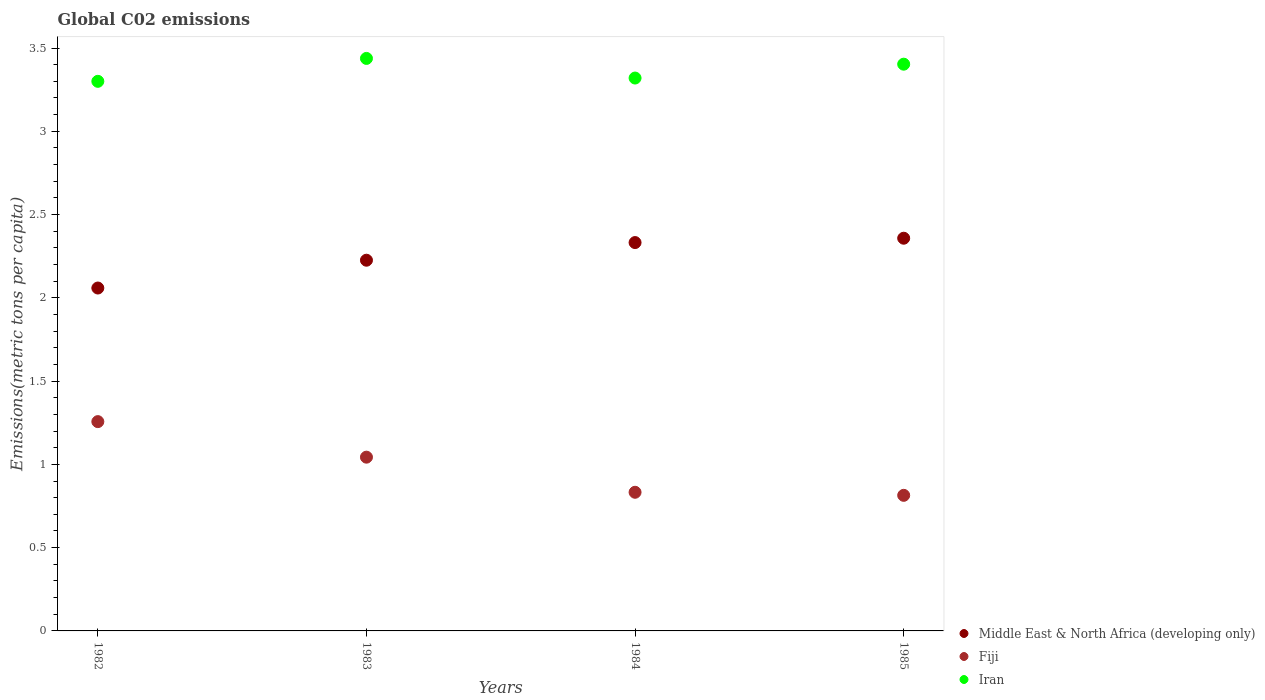Is the number of dotlines equal to the number of legend labels?
Ensure brevity in your answer.  Yes. What is the amount of CO2 emitted in in Middle East & North Africa (developing only) in 1983?
Your answer should be compact. 2.23. Across all years, what is the maximum amount of CO2 emitted in in Fiji?
Offer a very short reply. 1.26. Across all years, what is the minimum amount of CO2 emitted in in Fiji?
Provide a short and direct response. 0.81. What is the total amount of CO2 emitted in in Middle East & North Africa (developing only) in the graph?
Keep it short and to the point. 8.97. What is the difference between the amount of CO2 emitted in in Middle East & North Africa (developing only) in 1983 and that in 1985?
Provide a succinct answer. -0.13. What is the difference between the amount of CO2 emitted in in Fiji in 1984 and the amount of CO2 emitted in in Iran in 1983?
Give a very brief answer. -2.61. What is the average amount of CO2 emitted in in Iran per year?
Give a very brief answer. 3.37. In the year 1982, what is the difference between the amount of CO2 emitted in in Iran and amount of CO2 emitted in in Fiji?
Ensure brevity in your answer.  2.04. In how many years, is the amount of CO2 emitted in in Fiji greater than 3 metric tons per capita?
Offer a terse response. 0. What is the ratio of the amount of CO2 emitted in in Middle East & North Africa (developing only) in 1983 to that in 1985?
Make the answer very short. 0.94. Is the amount of CO2 emitted in in Iran in 1984 less than that in 1985?
Offer a terse response. Yes. Is the difference between the amount of CO2 emitted in in Iran in 1982 and 1984 greater than the difference between the amount of CO2 emitted in in Fiji in 1982 and 1984?
Make the answer very short. No. What is the difference between the highest and the second highest amount of CO2 emitted in in Iran?
Ensure brevity in your answer.  0.03. What is the difference between the highest and the lowest amount of CO2 emitted in in Fiji?
Give a very brief answer. 0.44. Is it the case that in every year, the sum of the amount of CO2 emitted in in Middle East & North Africa (developing only) and amount of CO2 emitted in in Iran  is greater than the amount of CO2 emitted in in Fiji?
Your answer should be compact. Yes. Does the amount of CO2 emitted in in Iran monotonically increase over the years?
Offer a very short reply. No. Is the amount of CO2 emitted in in Iran strictly greater than the amount of CO2 emitted in in Middle East & North Africa (developing only) over the years?
Provide a short and direct response. Yes. Is the amount of CO2 emitted in in Middle East & North Africa (developing only) strictly less than the amount of CO2 emitted in in Iran over the years?
Provide a short and direct response. Yes. Are the values on the major ticks of Y-axis written in scientific E-notation?
Give a very brief answer. No. Does the graph contain grids?
Provide a short and direct response. No. How many legend labels are there?
Provide a short and direct response. 3. What is the title of the graph?
Keep it short and to the point. Global C02 emissions. Does "Antigua and Barbuda" appear as one of the legend labels in the graph?
Your response must be concise. No. What is the label or title of the Y-axis?
Make the answer very short. Emissions(metric tons per capita). What is the Emissions(metric tons per capita) in Middle East & North Africa (developing only) in 1982?
Your response must be concise. 2.06. What is the Emissions(metric tons per capita) of Fiji in 1982?
Your response must be concise. 1.26. What is the Emissions(metric tons per capita) of Iran in 1982?
Keep it short and to the point. 3.3. What is the Emissions(metric tons per capita) of Middle East & North Africa (developing only) in 1983?
Your answer should be very brief. 2.23. What is the Emissions(metric tons per capita) in Fiji in 1983?
Keep it short and to the point. 1.04. What is the Emissions(metric tons per capita) in Iran in 1983?
Provide a succinct answer. 3.44. What is the Emissions(metric tons per capita) of Middle East & North Africa (developing only) in 1984?
Your answer should be very brief. 2.33. What is the Emissions(metric tons per capita) in Fiji in 1984?
Make the answer very short. 0.83. What is the Emissions(metric tons per capita) of Iran in 1984?
Make the answer very short. 3.32. What is the Emissions(metric tons per capita) of Middle East & North Africa (developing only) in 1985?
Keep it short and to the point. 2.36. What is the Emissions(metric tons per capita) in Fiji in 1985?
Offer a terse response. 0.81. What is the Emissions(metric tons per capita) of Iran in 1985?
Provide a short and direct response. 3.4. Across all years, what is the maximum Emissions(metric tons per capita) in Middle East & North Africa (developing only)?
Offer a terse response. 2.36. Across all years, what is the maximum Emissions(metric tons per capita) of Fiji?
Your answer should be compact. 1.26. Across all years, what is the maximum Emissions(metric tons per capita) of Iran?
Ensure brevity in your answer.  3.44. Across all years, what is the minimum Emissions(metric tons per capita) in Middle East & North Africa (developing only)?
Ensure brevity in your answer.  2.06. Across all years, what is the minimum Emissions(metric tons per capita) in Fiji?
Your answer should be very brief. 0.81. Across all years, what is the minimum Emissions(metric tons per capita) in Iran?
Ensure brevity in your answer.  3.3. What is the total Emissions(metric tons per capita) in Middle East & North Africa (developing only) in the graph?
Make the answer very short. 8.97. What is the total Emissions(metric tons per capita) of Fiji in the graph?
Provide a succinct answer. 3.95. What is the total Emissions(metric tons per capita) of Iran in the graph?
Ensure brevity in your answer.  13.46. What is the difference between the Emissions(metric tons per capita) of Middle East & North Africa (developing only) in 1982 and that in 1983?
Make the answer very short. -0.17. What is the difference between the Emissions(metric tons per capita) of Fiji in 1982 and that in 1983?
Provide a succinct answer. 0.21. What is the difference between the Emissions(metric tons per capita) in Iran in 1982 and that in 1983?
Offer a terse response. -0.14. What is the difference between the Emissions(metric tons per capita) in Middle East & North Africa (developing only) in 1982 and that in 1984?
Make the answer very short. -0.27. What is the difference between the Emissions(metric tons per capita) of Fiji in 1982 and that in 1984?
Your answer should be very brief. 0.42. What is the difference between the Emissions(metric tons per capita) of Iran in 1982 and that in 1984?
Offer a very short reply. -0.02. What is the difference between the Emissions(metric tons per capita) in Middle East & North Africa (developing only) in 1982 and that in 1985?
Offer a very short reply. -0.3. What is the difference between the Emissions(metric tons per capita) of Fiji in 1982 and that in 1985?
Offer a very short reply. 0.44. What is the difference between the Emissions(metric tons per capita) of Iran in 1982 and that in 1985?
Give a very brief answer. -0.1. What is the difference between the Emissions(metric tons per capita) in Middle East & North Africa (developing only) in 1983 and that in 1984?
Offer a terse response. -0.11. What is the difference between the Emissions(metric tons per capita) in Fiji in 1983 and that in 1984?
Keep it short and to the point. 0.21. What is the difference between the Emissions(metric tons per capita) of Iran in 1983 and that in 1984?
Provide a succinct answer. 0.12. What is the difference between the Emissions(metric tons per capita) in Middle East & North Africa (developing only) in 1983 and that in 1985?
Ensure brevity in your answer.  -0.13. What is the difference between the Emissions(metric tons per capita) of Fiji in 1983 and that in 1985?
Provide a succinct answer. 0.23. What is the difference between the Emissions(metric tons per capita) in Iran in 1983 and that in 1985?
Provide a short and direct response. 0.03. What is the difference between the Emissions(metric tons per capita) of Middle East & North Africa (developing only) in 1984 and that in 1985?
Provide a succinct answer. -0.03. What is the difference between the Emissions(metric tons per capita) of Fiji in 1984 and that in 1985?
Provide a succinct answer. 0.02. What is the difference between the Emissions(metric tons per capita) in Iran in 1984 and that in 1985?
Your answer should be very brief. -0.08. What is the difference between the Emissions(metric tons per capita) in Middle East & North Africa (developing only) in 1982 and the Emissions(metric tons per capita) in Fiji in 1983?
Ensure brevity in your answer.  1.02. What is the difference between the Emissions(metric tons per capita) in Middle East & North Africa (developing only) in 1982 and the Emissions(metric tons per capita) in Iran in 1983?
Keep it short and to the point. -1.38. What is the difference between the Emissions(metric tons per capita) in Fiji in 1982 and the Emissions(metric tons per capita) in Iran in 1983?
Provide a succinct answer. -2.18. What is the difference between the Emissions(metric tons per capita) in Middle East & North Africa (developing only) in 1982 and the Emissions(metric tons per capita) in Fiji in 1984?
Your answer should be very brief. 1.23. What is the difference between the Emissions(metric tons per capita) in Middle East & North Africa (developing only) in 1982 and the Emissions(metric tons per capita) in Iran in 1984?
Provide a short and direct response. -1.26. What is the difference between the Emissions(metric tons per capita) of Fiji in 1982 and the Emissions(metric tons per capita) of Iran in 1984?
Your answer should be very brief. -2.06. What is the difference between the Emissions(metric tons per capita) of Middle East & North Africa (developing only) in 1982 and the Emissions(metric tons per capita) of Fiji in 1985?
Give a very brief answer. 1.24. What is the difference between the Emissions(metric tons per capita) in Middle East & North Africa (developing only) in 1982 and the Emissions(metric tons per capita) in Iran in 1985?
Your response must be concise. -1.34. What is the difference between the Emissions(metric tons per capita) in Fiji in 1982 and the Emissions(metric tons per capita) in Iran in 1985?
Provide a succinct answer. -2.15. What is the difference between the Emissions(metric tons per capita) in Middle East & North Africa (developing only) in 1983 and the Emissions(metric tons per capita) in Fiji in 1984?
Offer a very short reply. 1.39. What is the difference between the Emissions(metric tons per capita) of Middle East & North Africa (developing only) in 1983 and the Emissions(metric tons per capita) of Iran in 1984?
Your answer should be compact. -1.09. What is the difference between the Emissions(metric tons per capita) in Fiji in 1983 and the Emissions(metric tons per capita) in Iran in 1984?
Your answer should be very brief. -2.28. What is the difference between the Emissions(metric tons per capita) of Middle East & North Africa (developing only) in 1983 and the Emissions(metric tons per capita) of Fiji in 1985?
Your response must be concise. 1.41. What is the difference between the Emissions(metric tons per capita) of Middle East & North Africa (developing only) in 1983 and the Emissions(metric tons per capita) of Iran in 1985?
Your answer should be very brief. -1.18. What is the difference between the Emissions(metric tons per capita) in Fiji in 1983 and the Emissions(metric tons per capita) in Iran in 1985?
Provide a succinct answer. -2.36. What is the difference between the Emissions(metric tons per capita) in Middle East & North Africa (developing only) in 1984 and the Emissions(metric tons per capita) in Fiji in 1985?
Your response must be concise. 1.52. What is the difference between the Emissions(metric tons per capita) in Middle East & North Africa (developing only) in 1984 and the Emissions(metric tons per capita) in Iran in 1985?
Make the answer very short. -1.07. What is the difference between the Emissions(metric tons per capita) of Fiji in 1984 and the Emissions(metric tons per capita) of Iran in 1985?
Offer a very short reply. -2.57. What is the average Emissions(metric tons per capita) of Middle East & North Africa (developing only) per year?
Your response must be concise. 2.24. What is the average Emissions(metric tons per capita) of Fiji per year?
Provide a short and direct response. 0.99. What is the average Emissions(metric tons per capita) of Iran per year?
Your answer should be very brief. 3.37. In the year 1982, what is the difference between the Emissions(metric tons per capita) in Middle East & North Africa (developing only) and Emissions(metric tons per capita) in Fiji?
Offer a terse response. 0.8. In the year 1982, what is the difference between the Emissions(metric tons per capita) of Middle East & North Africa (developing only) and Emissions(metric tons per capita) of Iran?
Offer a very short reply. -1.24. In the year 1982, what is the difference between the Emissions(metric tons per capita) in Fiji and Emissions(metric tons per capita) in Iran?
Offer a terse response. -2.04. In the year 1983, what is the difference between the Emissions(metric tons per capita) of Middle East & North Africa (developing only) and Emissions(metric tons per capita) of Fiji?
Offer a very short reply. 1.18. In the year 1983, what is the difference between the Emissions(metric tons per capita) in Middle East & North Africa (developing only) and Emissions(metric tons per capita) in Iran?
Your answer should be very brief. -1.21. In the year 1983, what is the difference between the Emissions(metric tons per capita) of Fiji and Emissions(metric tons per capita) of Iran?
Give a very brief answer. -2.39. In the year 1984, what is the difference between the Emissions(metric tons per capita) in Middle East & North Africa (developing only) and Emissions(metric tons per capita) in Fiji?
Keep it short and to the point. 1.5. In the year 1984, what is the difference between the Emissions(metric tons per capita) of Middle East & North Africa (developing only) and Emissions(metric tons per capita) of Iran?
Provide a succinct answer. -0.99. In the year 1984, what is the difference between the Emissions(metric tons per capita) of Fiji and Emissions(metric tons per capita) of Iran?
Provide a short and direct response. -2.49. In the year 1985, what is the difference between the Emissions(metric tons per capita) in Middle East & North Africa (developing only) and Emissions(metric tons per capita) in Fiji?
Ensure brevity in your answer.  1.54. In the year 1985, what is the difference between the Emissions(metric tons per capita) of Middle East & North Africa (developing only) and Emissions(metric tons per capita) of Iran?
Your answer should be very brief. -1.04. In the year 1985, what is the difference between the Emissions(metric tons per capita) in Fiji and Emissions(metric tons per capita) in Iran?
Give a very brief answer. -2.59. What is the ratio of the Emissions(metric tons per capita) in Middle East & North Africa (developing only) in 1982 to that in 1983?
Your answer should be very brief. 0.93. What is the ratio of the Emissions(metric tons per capita) of Fiji in 1982 to that in 1983?
Your answer should be compact. 1.2. What is the ratio of the Emissions(metric tons per capita) of Middle East & North Africa (developing only) in 1982 to that in 1984?
Make the answer very short. 0.88. What is the ratio of the Emissions(metric tons per capita) in Fiji in 1982 to that in 1984?
Ensure brevity in your answer.  1.51. What is the ratio of the Emissions(metric tons per capita) in Middle East & North Africa (developing only) in 1982 to that in 1985?
Your answer should be very brief. 0.87. What is the ratio of the Emissions(metric tons per capita) of Fiji in 1982 to that in 1985?
Provide a short and direct response. 1.54. What is the ratio of the Emissions(metric tons per capita) of Iran in 1982 to that in 1985?
Offer a terse response. 0.97. What is the ratio of the Emissions(metric tons per capita) in Middle East & North Africa (developing only) in 1983 to that in 1984?
Keep it short and to the point. 0.95. What is the ratio of the Emissions(metric tons per capita) of Fiji in 1983 to that in 1984?
Provide a short and direct response. 1.25. What is the ratio of the Emissions(metric tons per capita) of Iran in 1983 to that in 1984?
Offer a very short reply. 1.04. What is the ratio of the Emissions(metric tons per capita) of Middle East & North Africa (developing only) in 1983 to that in 1985?
Offer a terse response. 0.94. What is the ratio of the Emissions(metric tons per capita) in Fiji in 1983 to that in 1985?
Give a very brief answer. 1.28. What is the ratio of the Emissions(metric tons per capita) in Iran in 1983 to that in 1985?
Offer a very short reply. 1.01. What is the ratio of the Emissions(metric tons per capita) in Middle East & North Africa (developing only) in 1984 to that in 1985?
Your response must be concise. 0.99. What is the ratio of the Emissions(metric tons per capita) in Fiji in 1984 to that in 1985?
Offer a very short reply. 1.02. What is the ratio of the Emissions(metric tons per capita) of Iran in 1984 to that in 1985?
Offer a very short reply. 0.98. What is the difference between the highest and the second highest Emissions(metric tons per capita) of Middle East & North Africa (developing only)?
Offer a terse response. 0.03. What is the difference between the highest and the second highest Emissions(metric tons per capita) of Fiji?
Offer a very short reply. 0.21. What is the difference between the highest and the second highest Emissions(metric tons per capita) of Iran?
Make the answer very short. 0.03. What is the difference between the highest and the lowest Emissions(metric tons per capita) of Middle East & North Africa (developing only)?
Ensure brevity in your answer.  0.3. What is the difference between the highest and the lowest Emissions(metric tons per capita) of Fiji?
Keep it short and to the point. 0.44. What is the difference between the highest and the lowest Emissions(metric tons per capita) in Iran?
Your answer should be very brief. 0.14. 